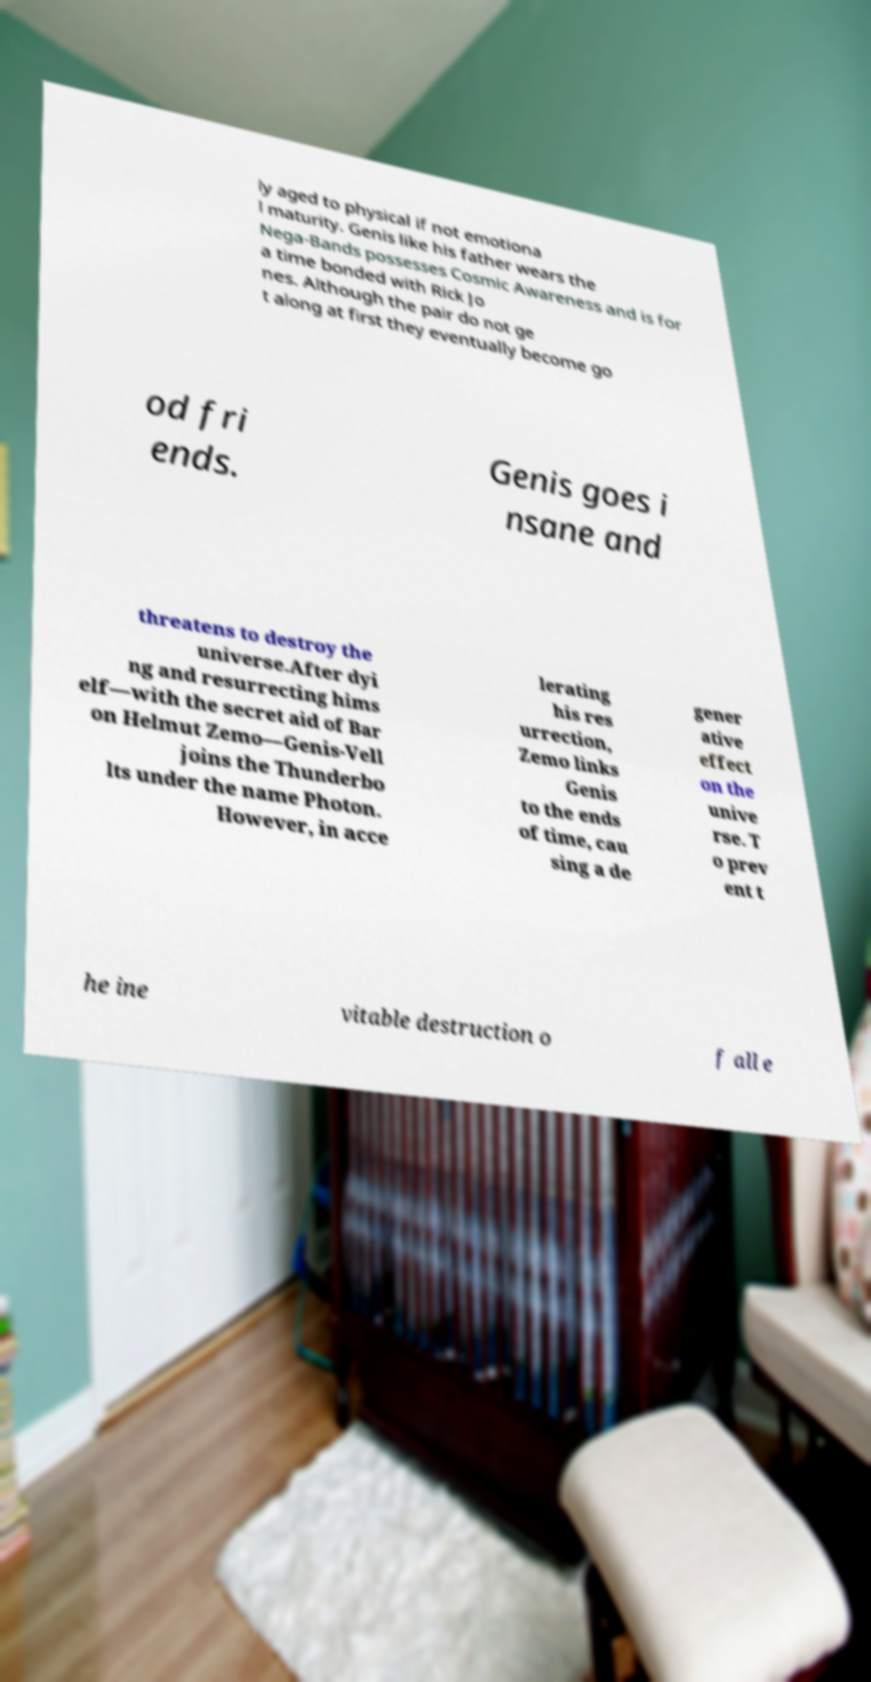For documentation purposes, I need the text within this image transcribed. Could you provide that? ly aged to physical if not emotiona l maturity. Genis like his father wears the Nega-Bands possesses Cosmic Awareness and is for a time bonded with Rick Jo nes. Although the pair do not ge t along at first they eventually become go od fri ends. Genis goes i nsane and threatens to destroy the universe.After dyi ng and resurrecting hims elf—with the secret aid of Bar on Helmut Zemo—Genis-Vell joins the Thunderbo lts under the name Photon. However, in acce lerating his res urrection, Zemo links Genis to the ends of time, cau sing a de gener ative effect on the unive rse. T o prev ent t he ine vitable destruction o f all e 